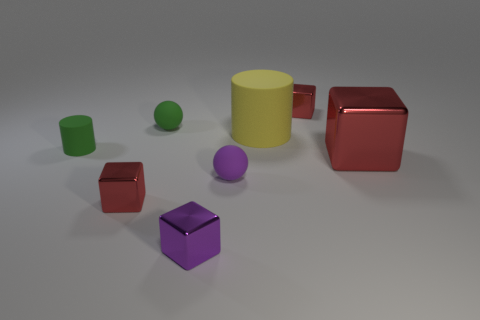What material is the small object that is the same color as the tiny rubber cylinder?
Keep it short and to the point. Rubber. The matte ball that is the same color as the small cylinder is what size?
Offer a very short reply. Small. What is the color of the tiny cylinder?
Your answer should be compact. Green. There is a red metallic thing that is left of the yellow matte cylinder; is its size the same as the cylinder in front of the large yellow thing?
Ensure brevity in your answer.  Yes. Are there fewer tiny green cubes than purple cubes?
Provide a short and direct response. Yes. There is a large rubber thing; what number of small red blocks are in front of it?
Make the answer very short. 1. What is the material of the purple block?
Ensure brevity in your answer.  Metal. Do the big rubber cylinder and the big metal cube have the same color?
Give a very brief answer. No. Are there fewer red metallic things on the left side of the green cylinder than tiny yellow matte balls?
Your response must be concise. No. There is a small sphere that is behind the yellow cylinder; what color is it?
Give a very brief answer. Green. 